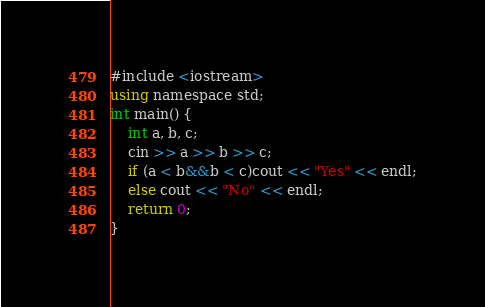Convert code to text. <code><loc_0><loc_0><loc_500><loc_500><_C#_>#include <iostream>
using namespace std;
int main() {
	int a, b, c;
	cin >> a >> b >> c;
	if (a < b&&b < c)cout << "Yes" << endl;
	else cout << "No" << endl;
	return 0;
}
</code> 